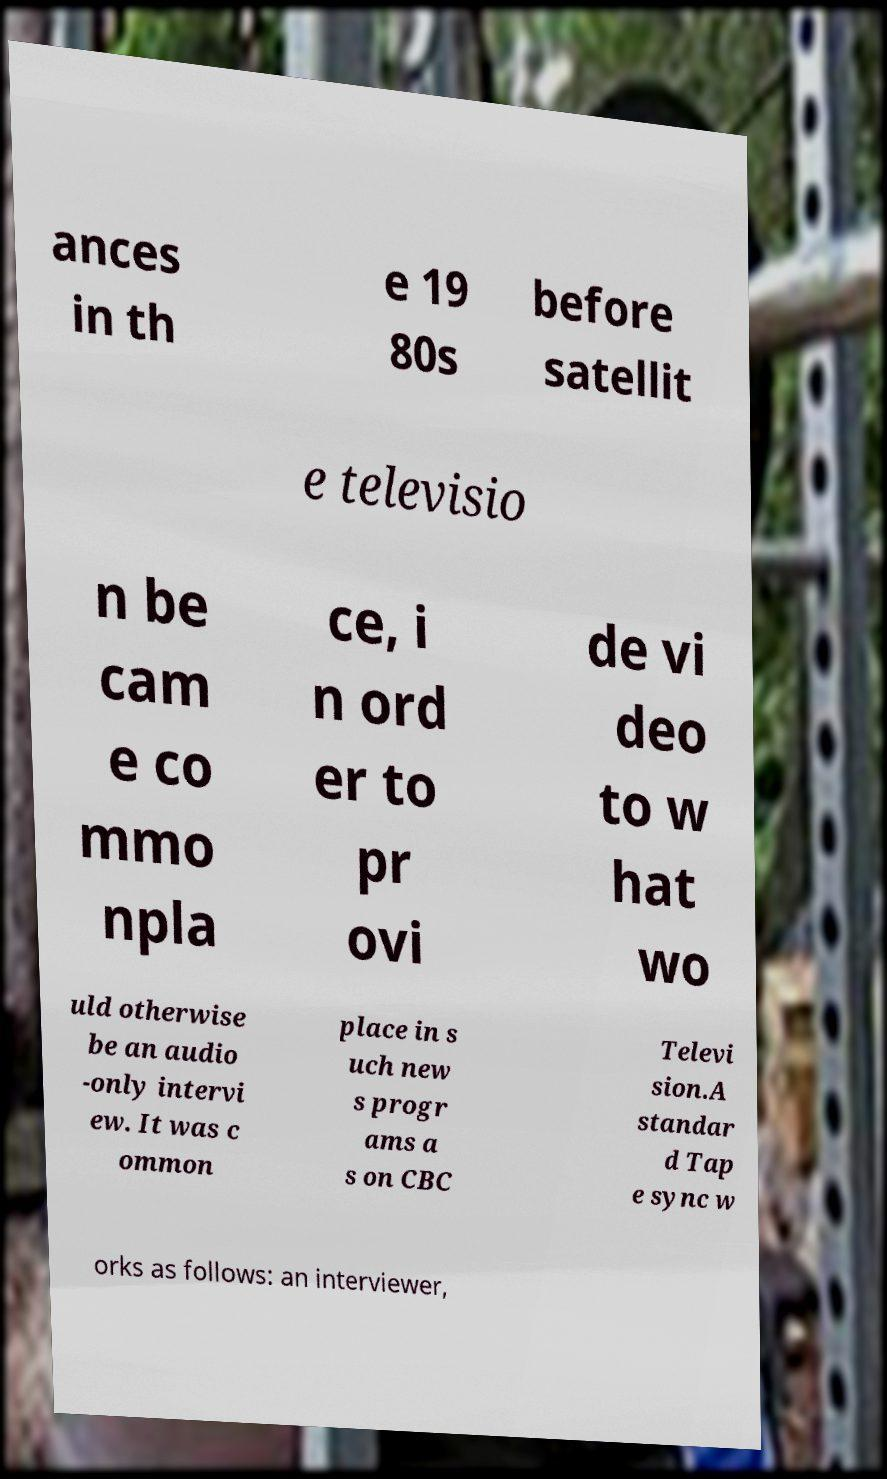Please identify and transcribe the text found in this image. ances in th e 19 80s before satellit e televisio n be cam e co mmo npla ce, i n ord er to pr ovi de vi deo to w hat wo uld otherwise be an audio -only intervi ew. It was c ommon place in s uch new s progr ams a s on CBC Televi sion.A standar d Tap e sync w orks as follows: an interviewer, 